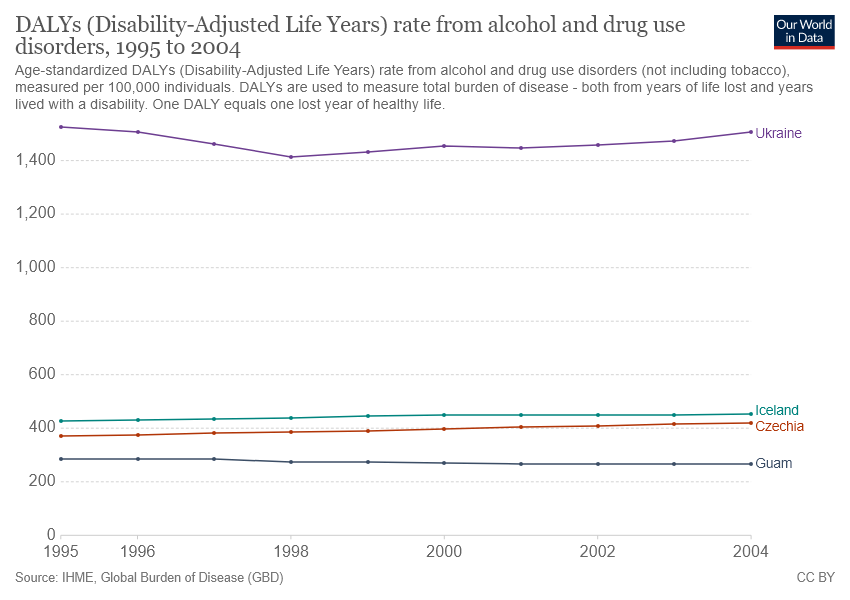Draw attention to some important aspects in this diagram. There are currently two countries that have DALY rates over 400 in the world. The country represented by the red color line is Czechia. 